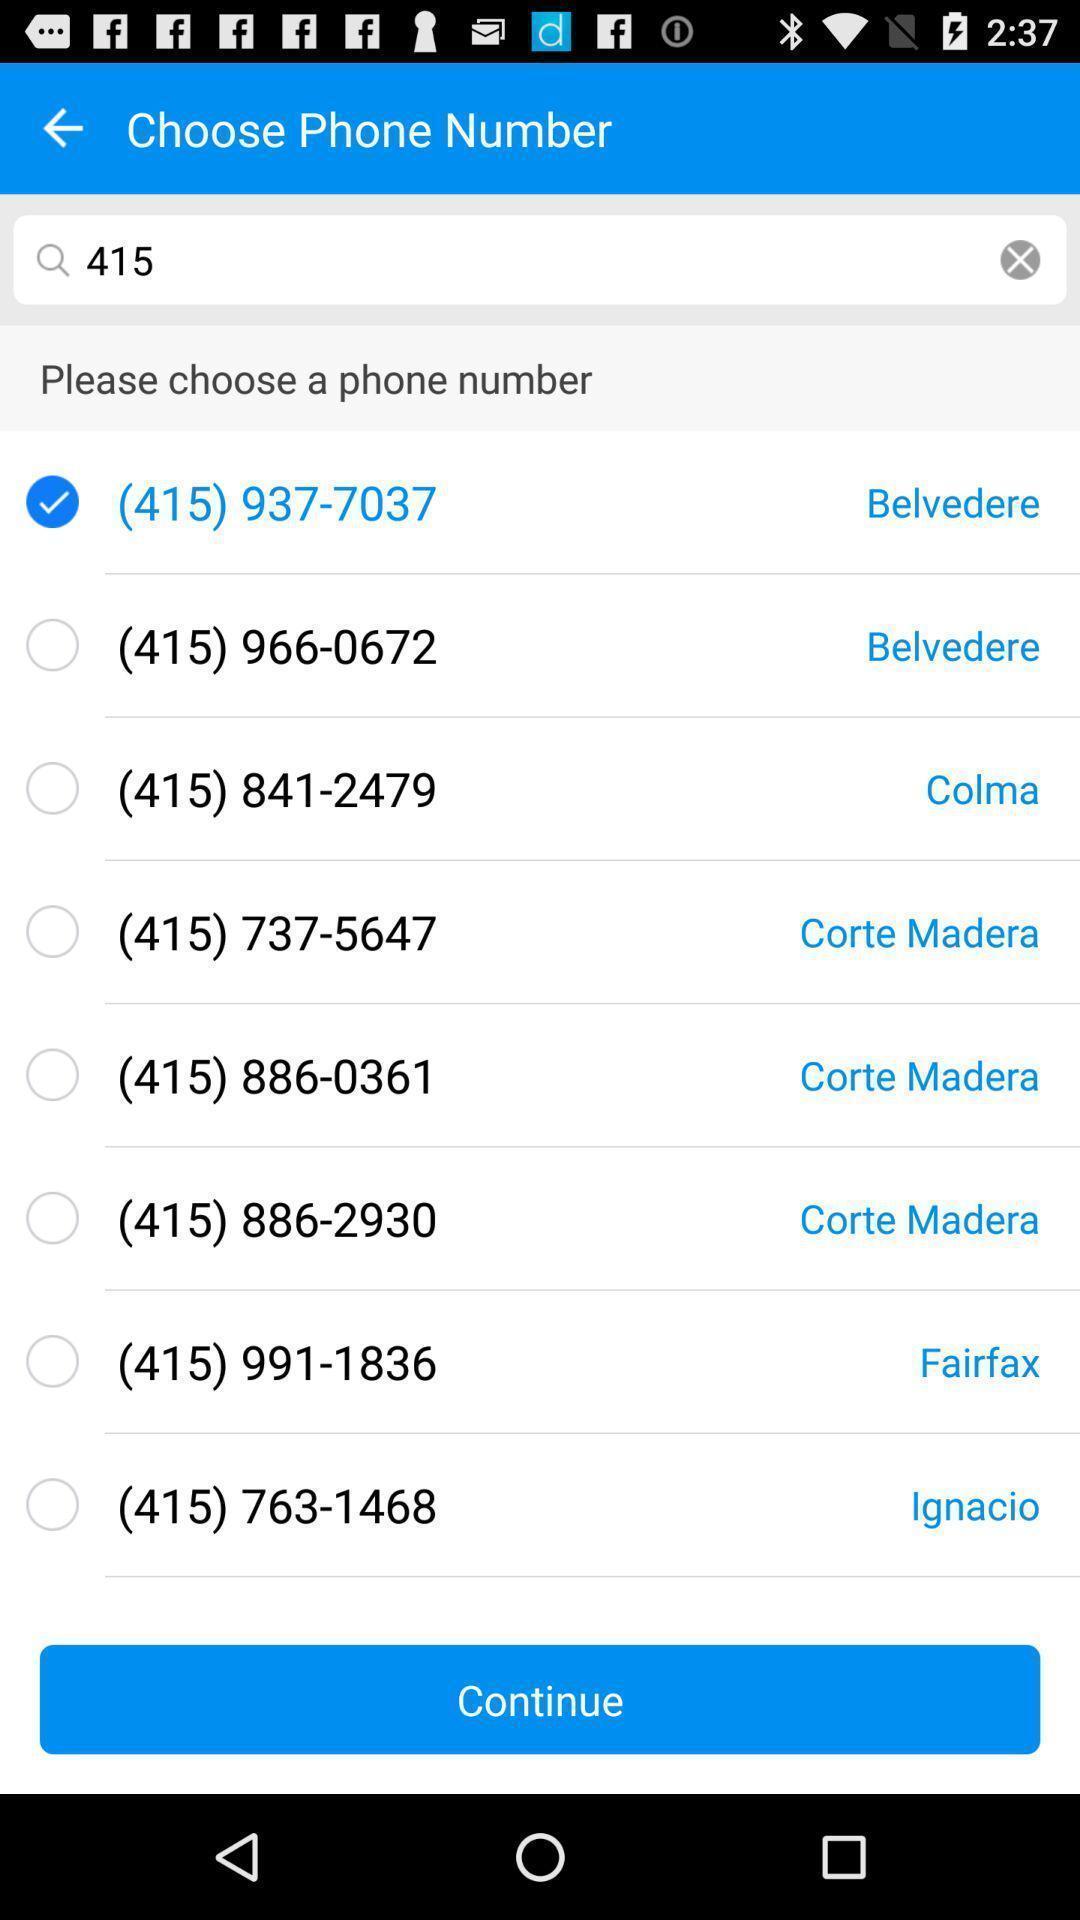Tell me about the visual elements in this screen capture. Page displaying with list of phone numbers to select. 